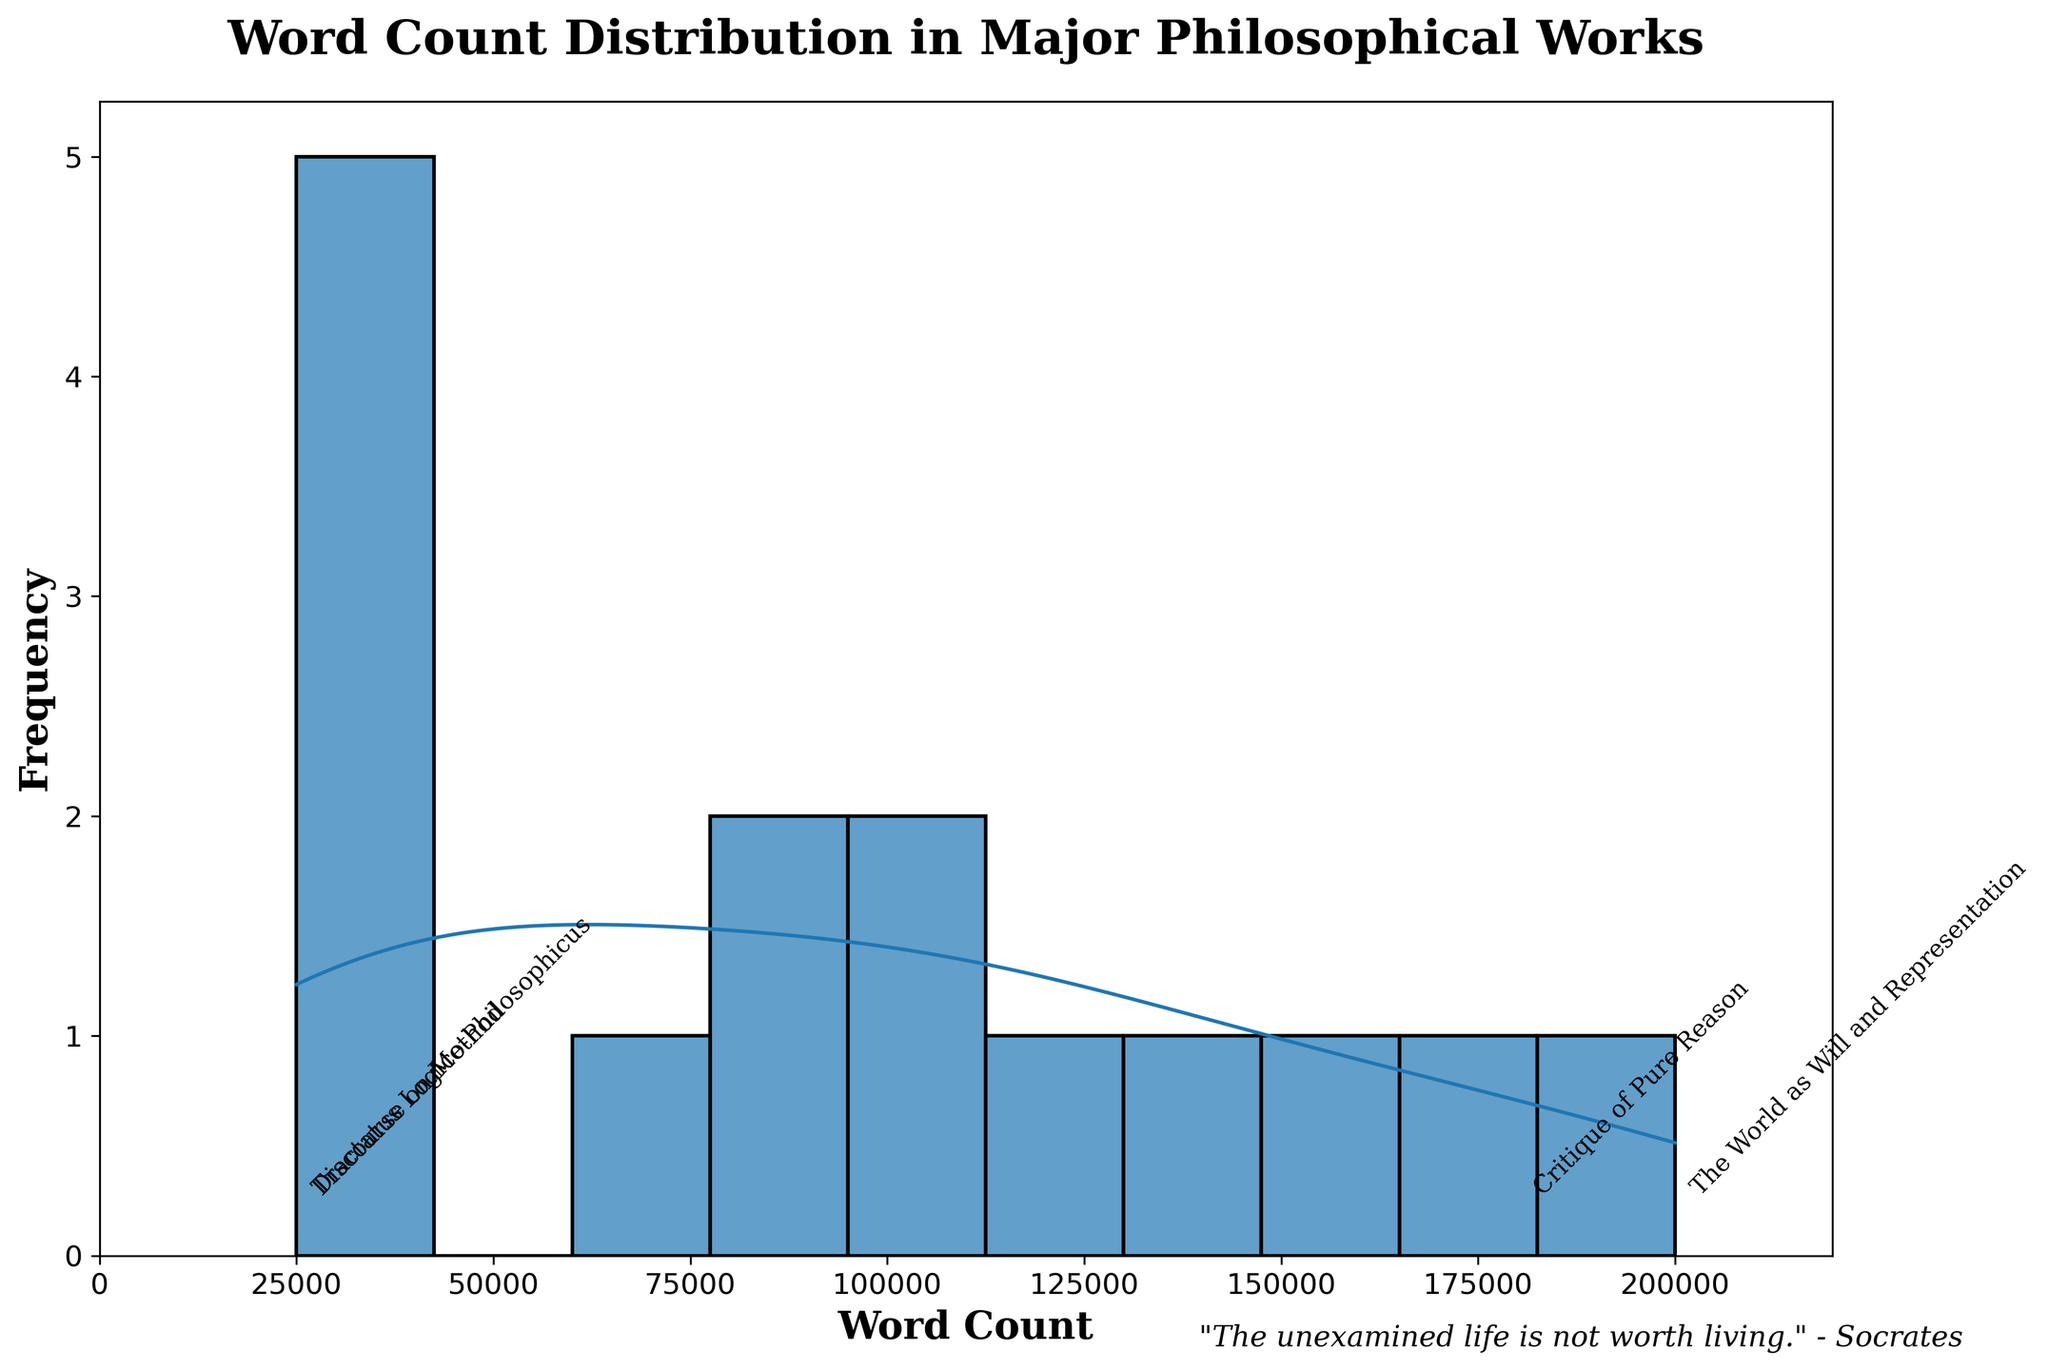What is the title of the plot? The title is displayed at the top of the figure. It is "Word Count Distribution in Major Philosophical Works".
Answer: Word Count Distribution in Major Philosophical Works Which philosophical work has the highest word count? Look at the annotations and the KDE curve. "The World as Will and Representation" by Arthur Schopenhauer is labeled and has the highest peak at around 200,000 word count.
Answer: The World as Will and Representation by Arthur Schopenhauer What is the range of the x-axis? The x-axis range can be determined by looking at the axis markers. It goes from 0 to slightly above 200,000.
Answer: 0 to 220,000 Which works have word counts below 30,000? Refer to the annotations and the histogram bars. "Tractatus Logico-Philosophicus" by Ludwig Wittgenstein and "Discourse on Method" by René Descartes are listed.
Answer: Tractatus Logico-Philosophicus and Discourse on Method What is the central tendency typically showcased by the density curve (KDE)? Observing the KDE curve shows the highest density around 75,000 to 100,000 words, indicating the central tendency.
Answer: Around 75,000 to 100,000 words How many works have a word count greater than 150,000? Check the histogram bars and annotations. There are 3 works: "Critique of Pure Reason" by Immanuel Kant, "The World as Will and Representation" by Arthur Schopenhauer, and "Being and Nothingness" by Jean-Paul Sartre.
Answer: 3 works Compare the word count between "Beyond Good and Evil" and "Thus Spoke Zarathustra". Which one is longer? Locate both titles in the annotations. "Thus Spoke Zarathustra" has 85,000 words, while "Beyond Good and Evil" has 65,000 words. Thus, "Thus Spoke Zarathustra" is longer.
Answer: Thus Spoke Zarathustra What is the approximate average word count of "The Republic" and "Ethics"? Add the word counts of both works (120,000 and 110,000) and divide by 2. The average is (120,000 + 110,000) / 2 = 115,000.
Answer: 115,000 How does the frequency change as word count increases beyond 100,000? The histogram bars show a general decrease in frequency as word count exceeds 100,000, indicated by fewer bars and lower heights in this range.
Answer: Decreases Which work marked on the chart has the closest word count to 50,000? The annotations near the 50,000 mark lists "The Myth of Sisyphus" by Albert Camus at approximately 40,000 words, which is the closest.
Answer: The Myth of Sisyphus 